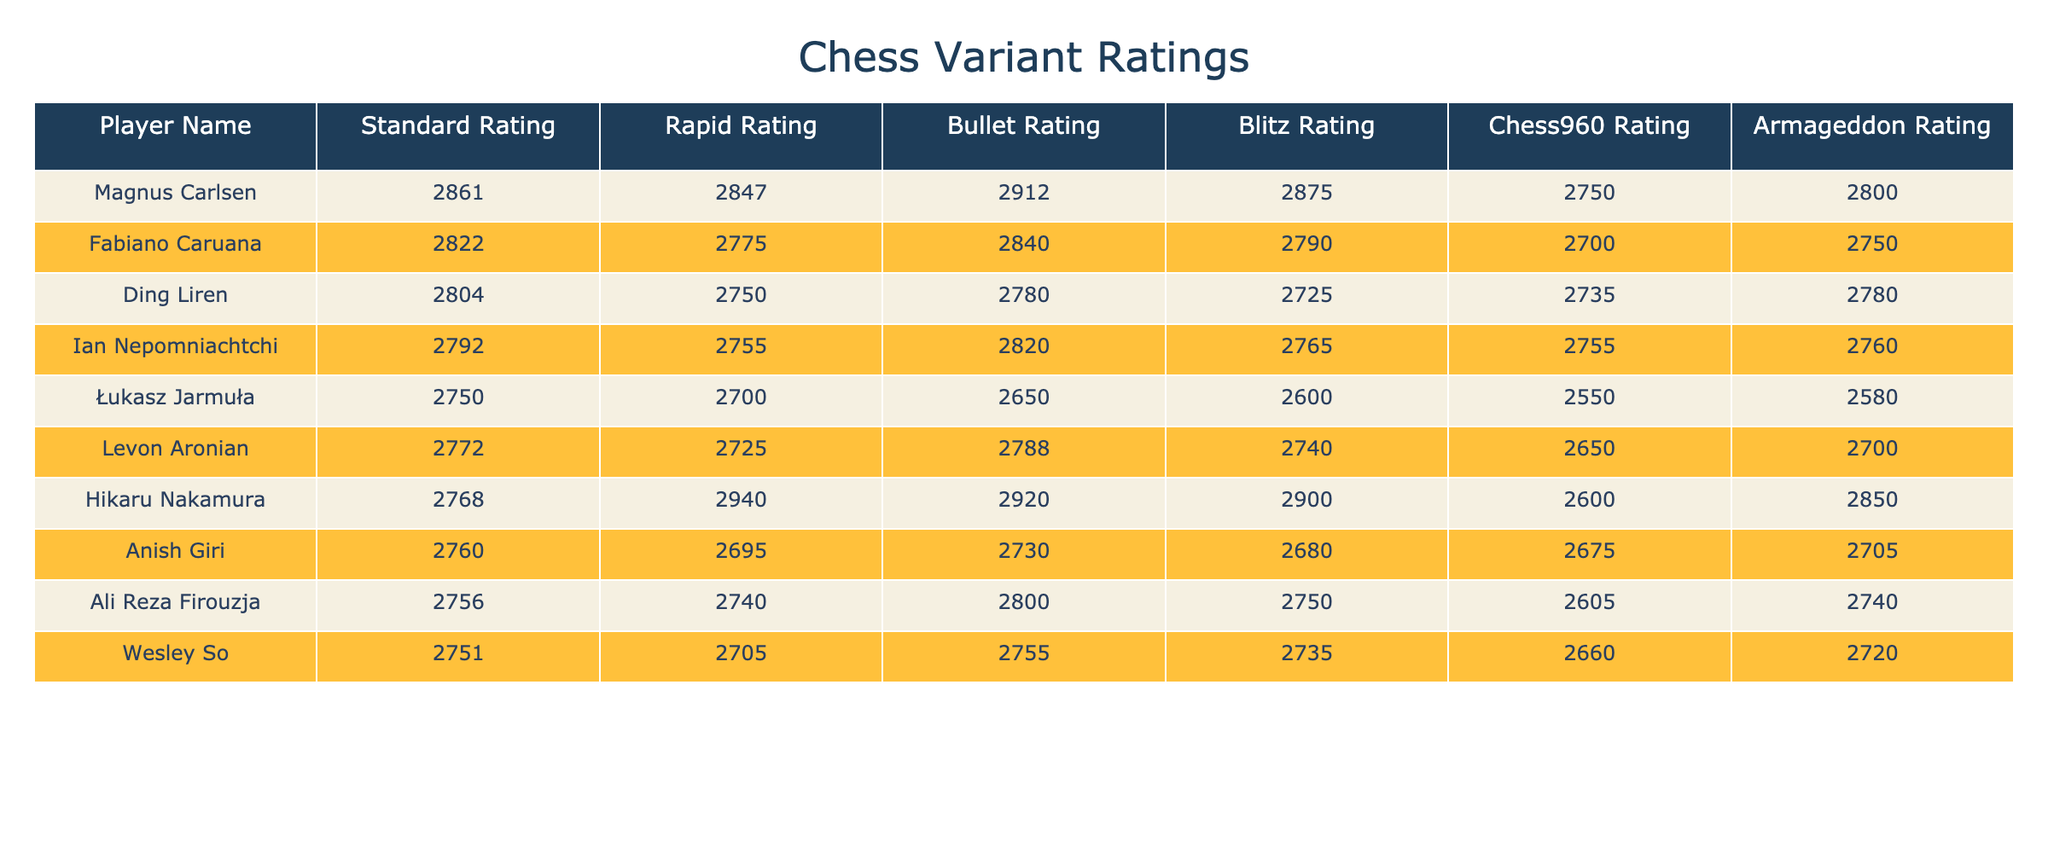What is Łukasz Jarmuła's Standard Rating? The table shows that Łukasz Jarmuła has a Standard Rating of 2750.
Answer: 2750 Who has the highest Bullet Rating? Checking the Bullet Ratings, Magnus Carlsen has the highest at 2912.
Answer: Magnus Carlsen Which player has the lowest Blitz Rating? Looking at the Blitz Ratings, Łukasz Jarmuła has the lowest Blitz Rating of 2600.
Answer: Łukasz Jarmuła What is the difference between Magnus Carlsen's Standard Rating and Ian Nepomniachtchi's Standard Rating? Magnus Carlsen has a Standard Rating of 2861, while Ian Nepomniachtchi has 2792. The difference is 2861 - 2792 = 69.
Answer: 69 What is the average Rapid Rating of the players in the table? Summing up all the Rapid Ratings (2847 + 2775 + 2750 + 2755 + 2700 + 2725 + 2940 + 2695 + 2740 + 2705 = 27662) and dividing by the number of players (10), gives an average of 2766.2.
Answer: 2766.2 Does Hikaru Nakamura have a higher Chess960 Rating than Fabiano Caruana? Hikaru Nakamura's Chess960 Rating is 2600, while Fabiano Caruana's is 2700. Since 2600 is less than 2700, the statement is false.
Answer: No What is the total of Armageddon Ratings for all players? Adding all the Armageddon Ratings (2800 + 2750 + 2780 + 2760 + 2580 + 2700 + 2850 + 2705 + 2740 + 2720 = 27565) gives a total of 27565.
Answer: 27565 Which player has the closest ratings in Blitz and Bullet? Comparing Blitz and Bullet Ratings, Hikaru Nakamura has a Bullet Rating of 2920 and a Blitz Rating of 2900, with a difference of 20, the closest among all players.
Answer: Hikaru Nakamura What is the ranking of players based on their highest rating across all variants? The highest ratings from each player are Magnus Carlsen (2861), Hikaru Nakamura (2940), Fabiano Caruana (2822), and so on, placing them in order: Magnus Carlsen, Hikaru Nakamura, etc.
Answer: Magnus Carlsen What percentage of players have a Standard Rating above 2750? There are 10 players total, with 6 players having a Standard Rating above 2750 (Magnus Carlsen, Fabiano Caruana, Ding Liren, Ian Nepomniachtchi, Levon Aronian, Hikaru Nakamura). Therefore, the percentage is (6/10)*100 = 60%.
Answer: 60% 